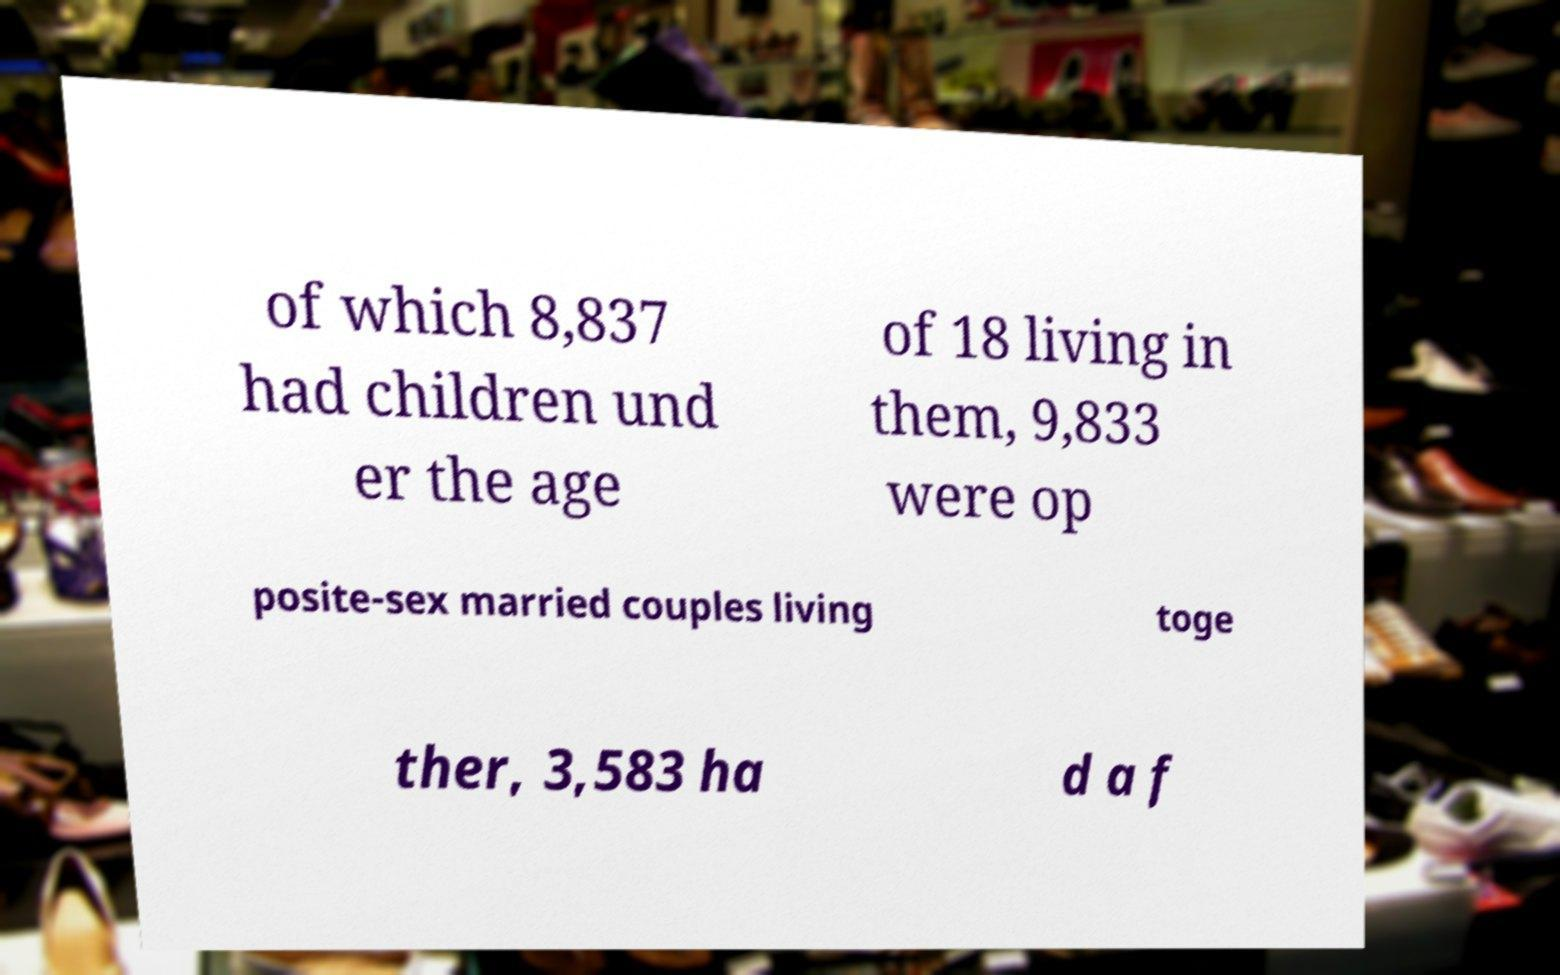What messages or text are displayed in this image? I need them in a readable, typed format. of which 8,837 had children und er the age of 18 living in them, 9,833 were op posite-sex married couples living toge ther, 3,583 ha d a f 